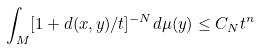<formula> <loc_0><loc_0><loc_500><loc_500>\int _ { M } [ 1 + d ( x , y ) / t ] ^ { - N } d \mu ( y ) \leq C _ { N } t ^ { n }</formula> 